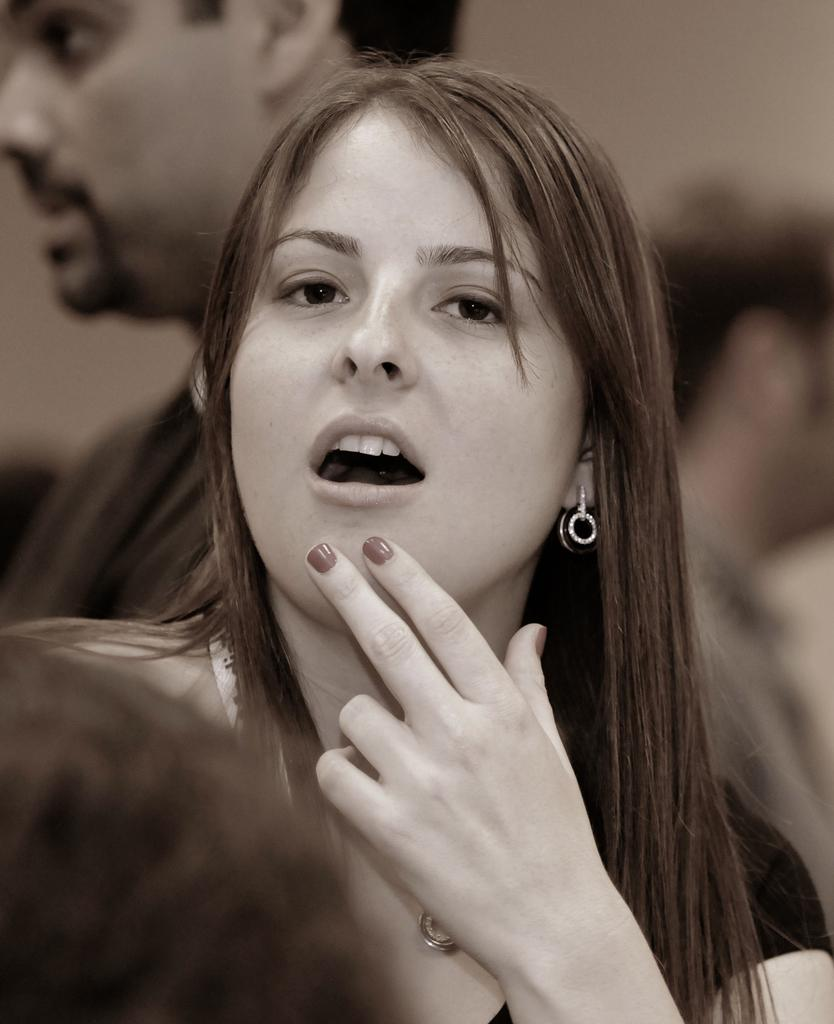Who is the main subject in the image? There is a woman in the image. Can you describe the person's head visible at the bottom of the image? Yes, there is a person's head visible at the bottom of the image. What else can be seen in the background of the image? There are other persons in the background of the image. What type of reward is the woman holding in the image? There is no reward visible in the image; the woman is the main subject, and no other objects are mentioned in the provided facts. 